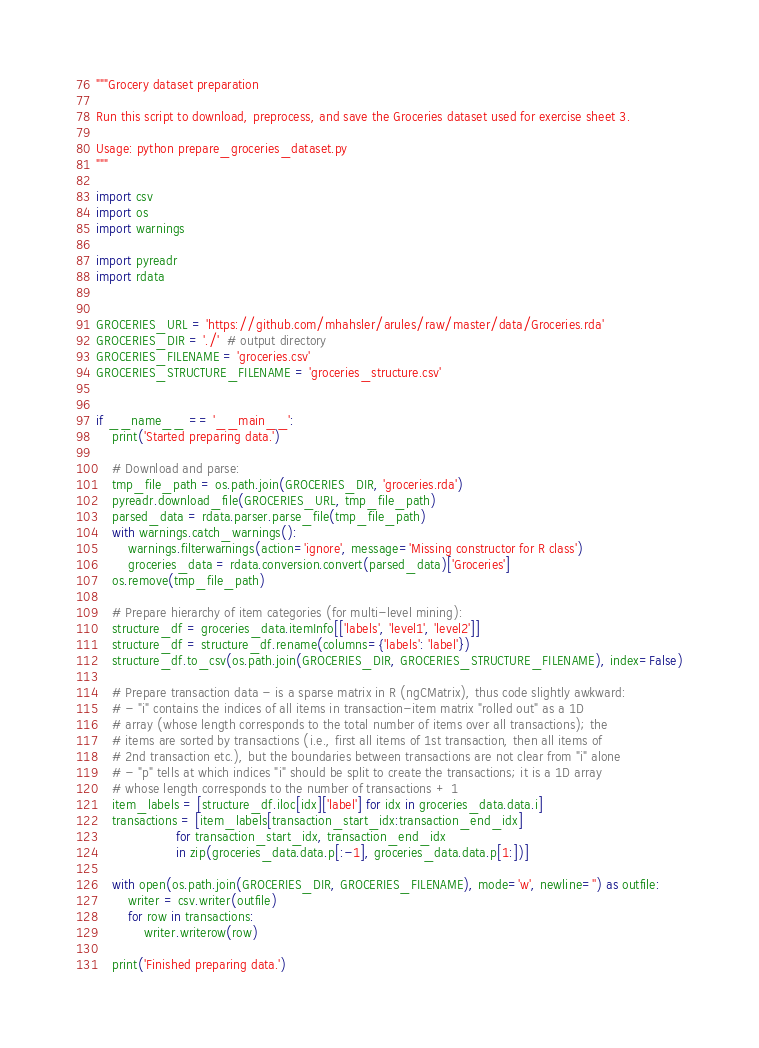Convert code to text. <code><loc_0><loc_0><loc_500><loc_500><_Python_>"""Grocery dataset preparation

Run this script to download, preprocess, and save the Groceries dataset used for exercise sheet 3.

Usage: python prepare_groceries_dataset.py
"""

import csv
import os
import warnings

import pyreadr
import rdata


GROCERIES_URL = 'https://github.com/mhahsler/arules/raw/master/data/Groceries.rda'
GROCERIES_DIR = './'  # output directory
GROCERIES_FILENAME = 'groceries.csv'
GROCERIES_STRUCTURE_FILENAME = 'groceries_structure.csv'


if __name__ == '__main__':
    print('Started preparing data.')

    # Download and parse:
    tmp_file_path = os.path.join(GROCERIES_DIR, 'groceries.rda')
    pyreadr.download_file(GROCERIES_URL, tmp_file_path)
    parsed_data = rdata.parser.parse_file(tmp_file_path)
    with warnings.catch_warnings():
        warnings.filterwarnings(action='ignore', message='Missing constructor for R class')
        groceries_data = rdata.conversion.convert(parsed_data)['Groceries']
    os.remove(tmp_file_path)

    # Prepare hierarchy of item categories (for multi-level mining):
    structure_df = groceries_data.itemInfo[['labels', 'level1', 'level2']]
    structure_df = structure_df.rename(columns={'labels': 'label'})
    structure_df.to_csv(os.path.join(GROCERIES_DIR, GROCERIES_STRUCTURE_FILENAME), index=False)

    # Prepare transaction data - is a sparse matrix in R (ngCMatrix), thus code slightly awkward:
    # - "i" contains the indices of all items in transaction-item matrix "rolled out" as a 1D
    # array (whose length corresponds to the total number of items over all transactions); the
    # items are sorted by transactions (i.e., first all items of 1st transaction, then all items of
    # 2nd transaction etc.), but the boundaries between transactions are not clear from "i" alone
    # - "p" tells at which indices "i" should be split to create the transactions; it is a 1D array
    # whose length corresponds to the number of transactions + 1
    item_labels = [structure_df.iloc[idx]['label'] for idx in groceries_data.data.i]
    transactions = [item_labels[transaction_start_idx:transaction_end_idx]
                    for transaction_start_idx, transaction_end_idx
                    in zip(groceries_data.data.p[:-1], groceries_data.data.p[1:])]

    with open(os.path.join(GROCERIES_DIR, GROCERIES_FILENAME), mode='w', newline='') as outfile:
        writer = csv.writer(outfile)
        for row in transactions:
            writer.writerow(row)

    print('Finished preparing data.')
</code> 